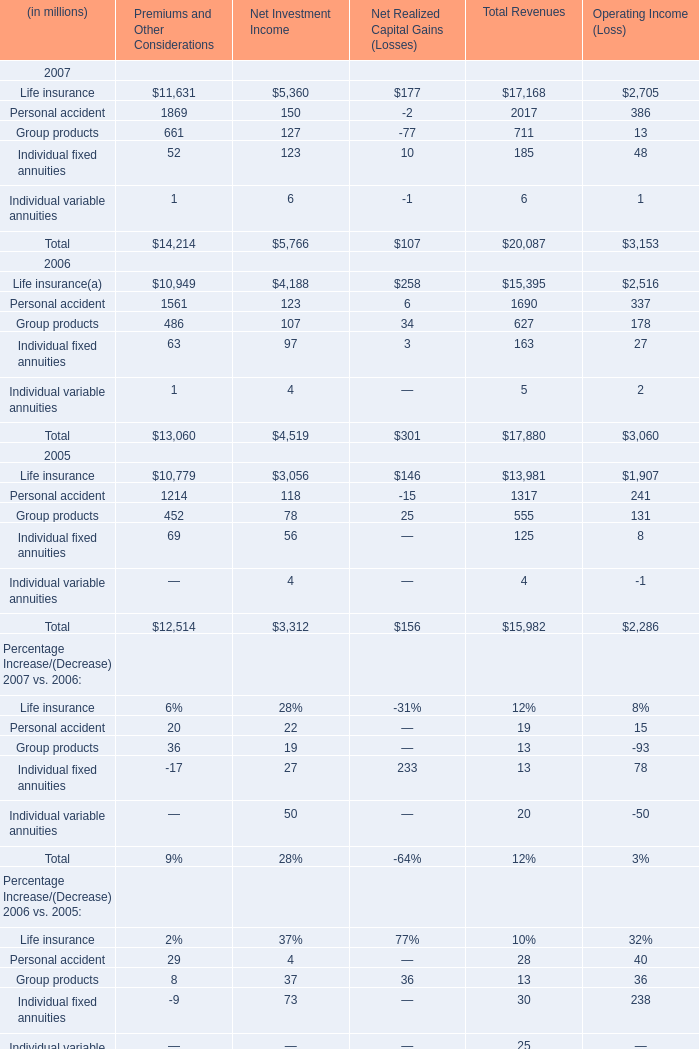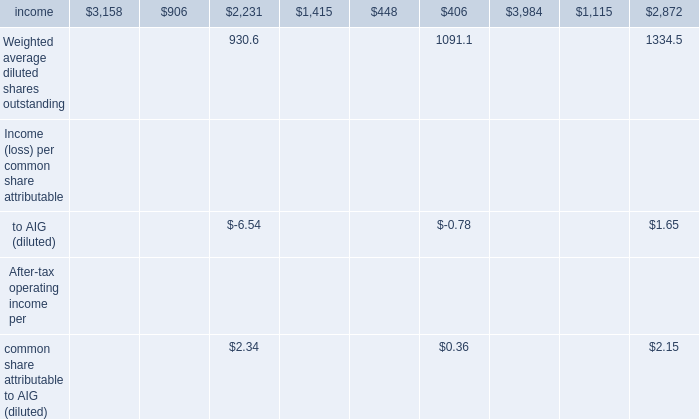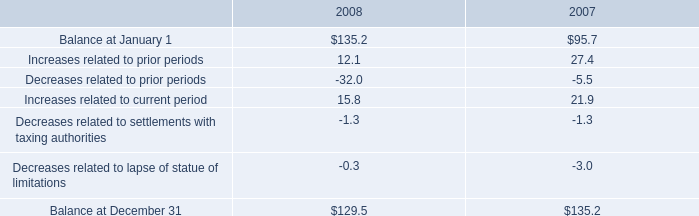Which year the Life insurance of Premiums and Other Considerations is the most? 
Answer: 2007. 